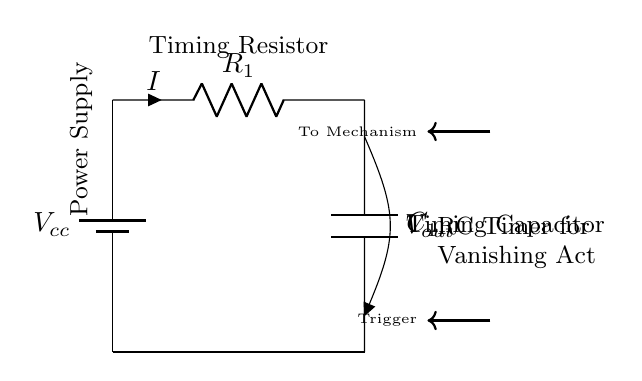What is the voltage source in this circuit? The circuit is powered by a battery, which provides the voltage source indicated as Vcc. The role of Vcc is to energize the circuit, allowing the resistive and capacitive elements to function.
Answer: Vcc What type of components are included in this circuit? The circuit consists of a resistor, a capacitor, and a battery as its main components, along with a voltage indicator Vout for measuring output voltage across the capacitor. These components work together to create a timing mechanism for the vanishing act.
Answer: Resistor, Capacitor, Battery What is the role of R1 in this circuit? R1, or the timing resistor, controls the charge and discharge rate of the capacitor (C1) in the circuit. The resistance affects the timing interval, determining how long it takes for the capacitor to charge to a certain voltage level, thereby controlling the duration of the illusion.
Answer: Timing Control What is the function of C1 in the RC circuit? C1, the timing capacitor, stores electrical energy. The time it takes for C1 to charge or discharge through R1 determines the timing control for the circuit, playing a critical role in synchronizing the illusion’s execution.
Answer: Timing Capacitor How is the output voltage represented in the circuit? Vout is marked at the junction between the resistor R1 and the capacitor C1, indicating the output voltage across the capacitor. This voltage is crucial in determining the timing characteristics and controlling the subsequent mechanisms of the illusion.
Answer: Vout 